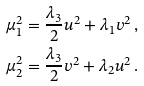<formula> <loc_0><loc_0><loc_500><loc_500>\mu _ { 1 } ^ { 2 } & = \frac { \lambda _ { 3 } } { 2 } u ^ { 2 } + \lambda _ { 1 } v ^ { 2 } \, , \\ \mu _ { 2 } ^ { 2 } & = \frac { \lambda _ { 3 } } { 2 } v ^ { 2 } + \lambda _ { 2 } u ^ { 2 } \, .</formula> 